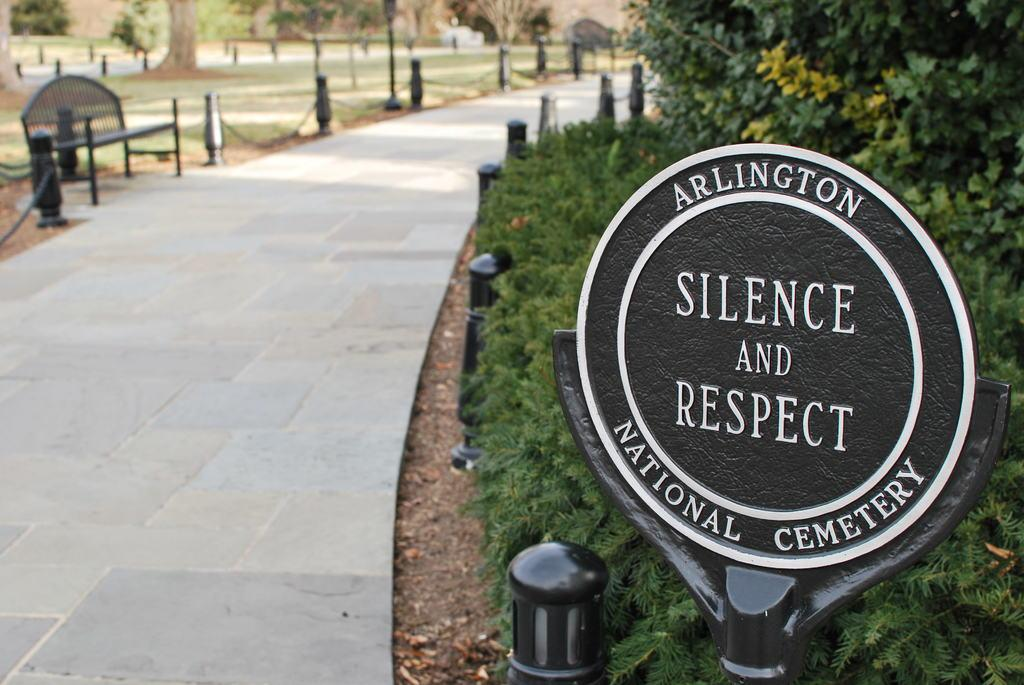What can be seen running through the trees and grass in the image? There is a path in the image that runs through the trees and grass. What is located along the path in the image? A bench is placed beside the path. What is written or displayed in the image? There is a board with text in the image. What type of zipper can be seen on the trees in the image? There are no zippers present on the trees in the image. What is the shape of the heart visible in the image? There is no heart shape visible in the image. 